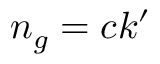Convert formula to latex. <formula><loc_0><loc_0><loc_500><loc_500>n _ { g } = c k ^ { \prime }</formula> 